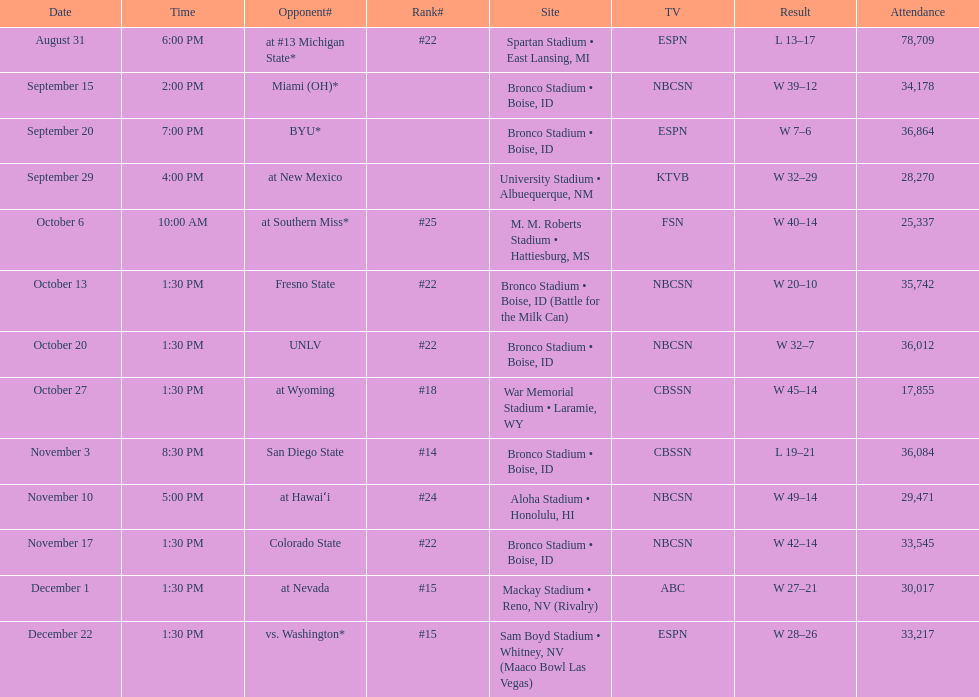Which team has the highest rank among those listed? San Diego State. Parse the table in full. {'header': ['Date', 'Time', 'Opponent#', 'Rank#', 'Site', 'TV', 'Result', 'Attendance'], 'rows': [['August 31', '6:00 PM', 'at\xa0#13\xa0Michigan State*', '#22', 'Spartan Stadium • East Lansing, MI', 'ESPN', 'L\xa013–17', '78,709'], ['September 15', '2:00 PM', 'Miami (OH)*', '', 'Bronco Stadium • Boise, ID', 'NBCSN', 'W\xa039–12', '34,178'], ['September 20', '7:00 PM', 'BYU*', '', 'Bronco Stadium • Boise, ID', 'ESPN', 'W\xa07–6', '36,864'], ['September 29', '4:00 PM', 'at\xa0New Mexico', '', 'University Stadium • Albuequerque, NM', 'KTVB', 'W\xa032–29', '28,270'], ['October 6', '10:00 AM', 'at\xa0Southern Miss*', '#25', 'M. M. Roberts Stadium • Hattiesburg, MS', 'FSN', 'W\xa040–14', '25,337'], ['October 13', '1:30 PM', 'Fresno State', '#22', 'Bronco Stadium • Boise, ID (Battle for the Milk Can)', 'NBCSN', 'W\xa020–10', '35,742'], ['October 20', '1:30 PM', 'UNLV', '#22', 'Bronco Stadium • Boise, ID', 'NBCSN', 'W\xa032–7', '36,012'], ['October 27', '1:30 PM', 'at\xa0Wyoming', '#18', 'War Memorial Stadium • Laramie, WY', 'CBSSN', 'W\xa045–14', '17,855'], ['November 3', '8:30 PM', 'San Diego State', '#14', 'Bronco Stadium • Boise, ID', 'CBSSN', 'L\xa019–21', '36,084'], ['November 10', '5:00 PM', 'at\xa0Hawaiʻi', '#24', 'Aloha Stadium • Honolulu, HI', 'NBCSN', 'W\xa049–14', '29,471'], ['November 17', '1:30 PM', 'Colorado State', '#22', 'Bronco Stadium • Boise, ID', 'NBCSN', 'W\xa042–14', '33,545'], ['December 1', '1:30 PM', 'at\xa0Nevada', '#15', 'Mackay Stadium • Reno, NV (Rivalry)', 'ABC', 'W\xa027–21', '30,017'], ['December 22', '1:30 PM', 'vs.\xa0Washington*', '#15', 'Sam Boyd Stadium • Whitney, NV (Maaco Bowl Las Vegas)', 'ESPN', 'W\xa028–26', '33,217']]} 